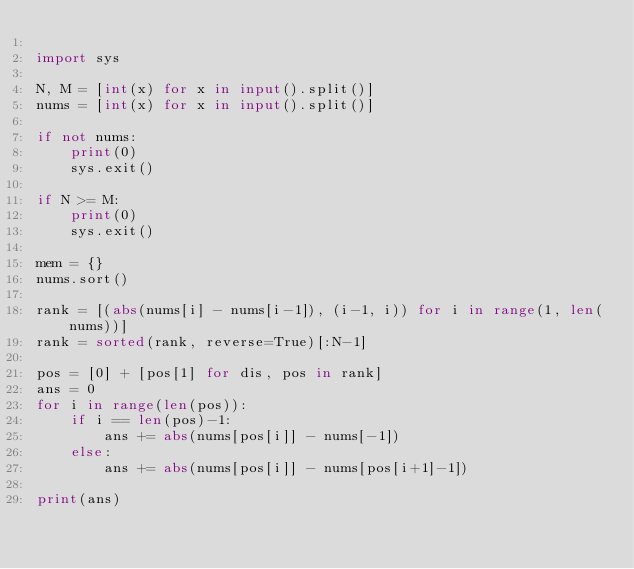Convert code to text. <code><loc_0><loc_0><loc_500><loc_500><_Python_>
import sys

N, M = [int(x) for x in input().split()]
nums = [int(x) for x in input().split()]

if not nums:
    print(0)
    sys.exit()

if N >= M:
    print(0)
    sys.exit()

mem = {}
nums.sort()

rank = [(abs(nums[i] - nums[i-1]), (i-1, i)) for i in range(1, len(nums))]
rank = sorted(rank, reverse=True)[:N-1]

pos = [0] + [pos[1] for dis, pos in rank]
ans = 0
for i in range(len(pos)):
    if i == len(pos)-1:
        ans += abs(nums[pos[i]] - nums[-1])
    else:
        ans += abs(nums[pos[i]] - nums[pos[i+1]-1])

print(ans)


</code> 